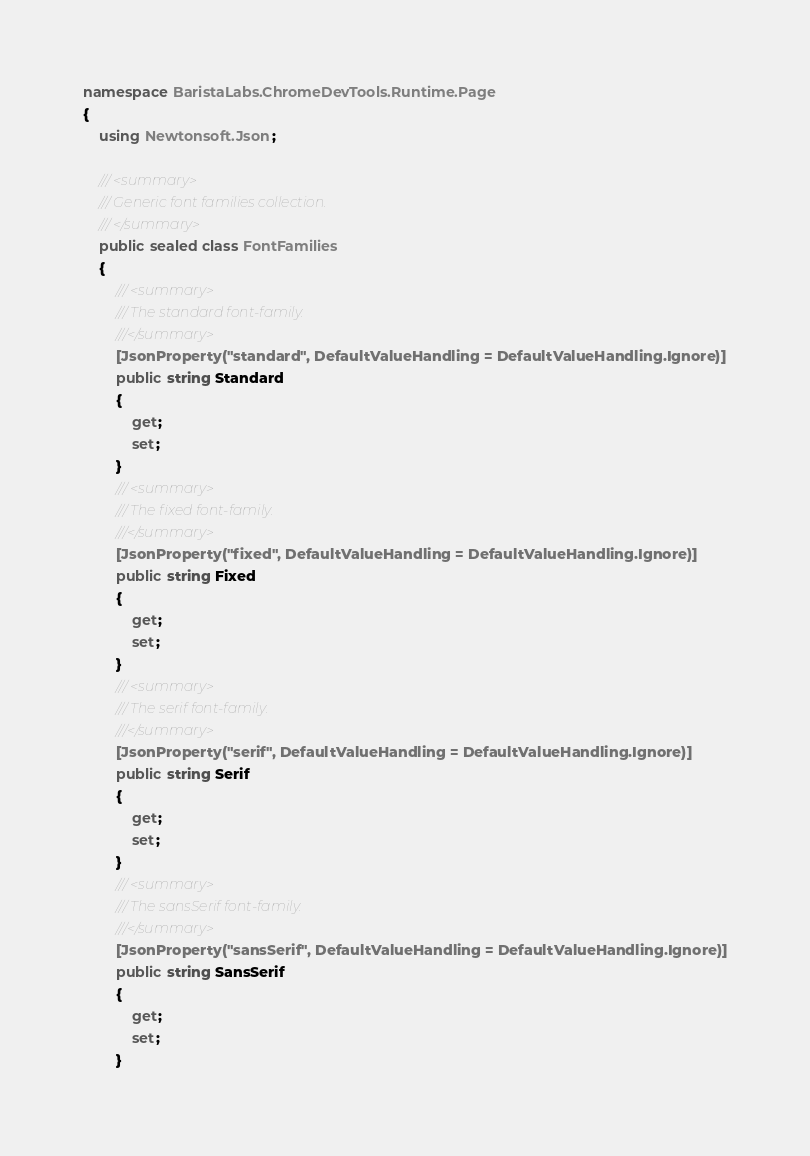Convert code to text. <code><loc_0><loc_0><loc_500><loc_500><_C#_>namespace BaristaLabs.ChromeDevTools.Runtime.Page
{
    using Newtonsoft.Json;

    /// <summary>
    /// Generic font families collection.
    /// </summary>
    public sealed class FontFamilies
    {
        /// <summary>
        /// The standard font-family.
        ///</summary>
        [JsonProperty("standard", DefaultValueHandling = DefaultValueHandling.Ignore)]
        public string Standard
        {
            get;
            set;
        }
        /// <summary>
        /// The fixed font-family.
        ///</summary>
        [JsonProperty("fixed", DefaultValueHandling = DefaultValueHandling.Ignore)]
        public string Fixed
        {
            get;
            set;
        }
        /// <summary>
        /// The serif font-family.
        ///</summary>
        [JsonProperty("serif", DefaultValueHandling = DefaultValueHandling.Ignore)]
        public string Serif
        {
            get;
            set;
        }
        /// <summary>
        /// The sansSerif font-family.
        ///</summary>
        [JsonProperty("sansSerif", DefaultValueHandling = DefaultValueHandling.Ignore)]
        public string SansSerif
        {
            get;
            set;
        }</code> 